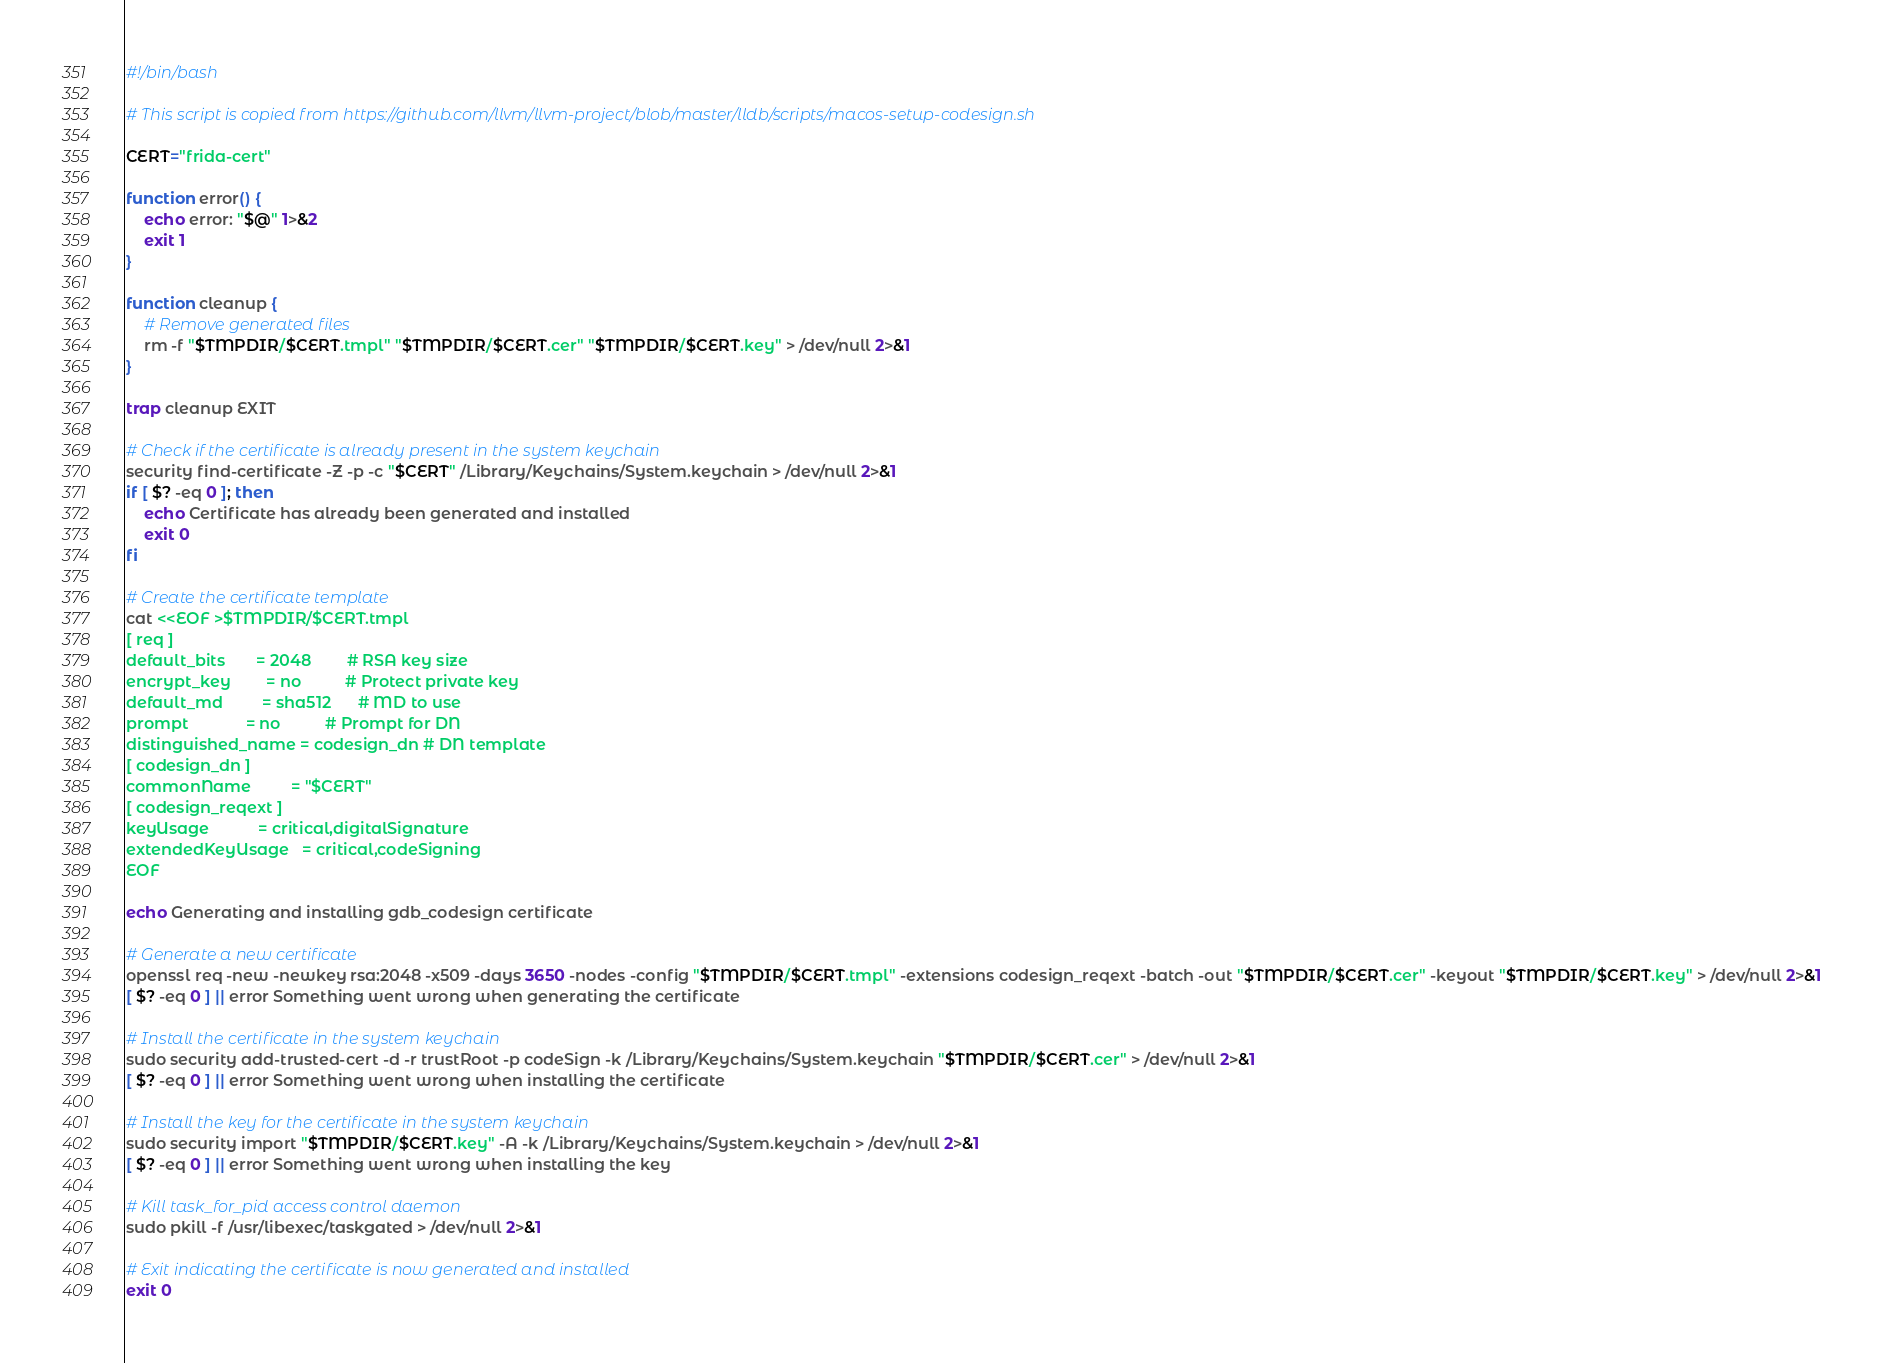<code> <loc_0><loc_0><loc_500><loc_500><_Bash_>#!/bin/bash

# This script is copied from https://github.com/llvm/llvm-project/blob/master/lldb/scripts/macos-setup-codesign.sh

CERT="frida-cert"

function error() {
    echo error: "$@" 1>&2
    exit 1
}

function cleanup {
    # Remove generated files
    rm -f "$TMPDIR/$CERT.tmpl" "$TMPDIR/$CERT.cer" "$TMPDIR/$CERT.key" > /dev/null 2>&1
}

trap cleanup EXIT

# Check if the certificate is already present in the system keychain
security find-certificate -Z -p -c "$CERT" /Library/Keychains/System.keychain > /dev/null 2>&1
if [ $? -eq 0 ]; then
    echo Certificate has already been generated and installed
    exit 0
fi

# Create the certificate template
cat <<EOF >$TMPDIR/$CERT.tmpl
[ req ]
default_bits       = 2048        # RSA key size
encrypt_key        = no          # Protect private key
default_md         = sha512      # MD to use
prompt             = no          # Prompt for DN
distinguished_name = codesign_dn # DN template
[ codesign_dn ]
commonName         = "$CERT"
[ codesign_reqext ]
keyUsage           = critical,digitalSignature
extendedKeyUsage   = critical,codeSigning
EOF

echo Generating and installing gdb_codesign certificate

# Generate a new certificate
openssl req -new -newkey rsa:2048 -x509 -days 3650 -nodes -config "$TMPDIR/$CERT.tmpl" -extensions codesign_reqext -batch -out "$TMPDIR/$CERT.cer" -keyout "$TMPDIR/$CERT.key" > /dev/null 2>&1
[ $? -eq 0 ] || error Something went wrong when generating the certificate

# Install the certificate in the system keychain
sudo security add-trusted-cert -d -r trustRoot -p codeSign -k /Library/Keychains/System.keychain "$TMPDIR/$CERT.cer" > /dev/null 2>&1
[ $? -eq 0 ] || error Something went wrong when installing the certificate

# Install the key for the certificate in the system keychain
sudo security import "$TMPDIR/$CERT.key" -A -k /Library/Keychains/System.keychain > /dev/null 2>&1
[ $? -eq 0 ] || error Something went wrong when installing the key

# Kill task_for_pid access control daemon
sudo pkill -f /usr/libexec/taskgated > /dev/null 2>&1

# Exit indicating the certificate is now generated and installed
exit 0
</code> 